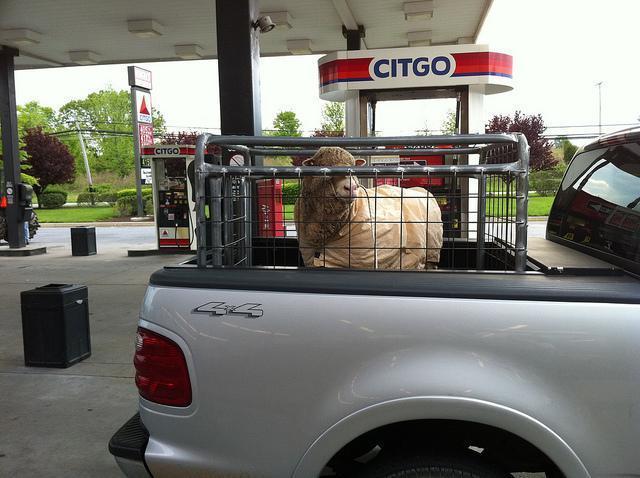Does the description: "The truck is behind the sheep." accurately reflect the image?
Answer yes or no. No. Is "The sheep is in the truck." an appropriate description for the image?
Answer yes or no. Yes. 